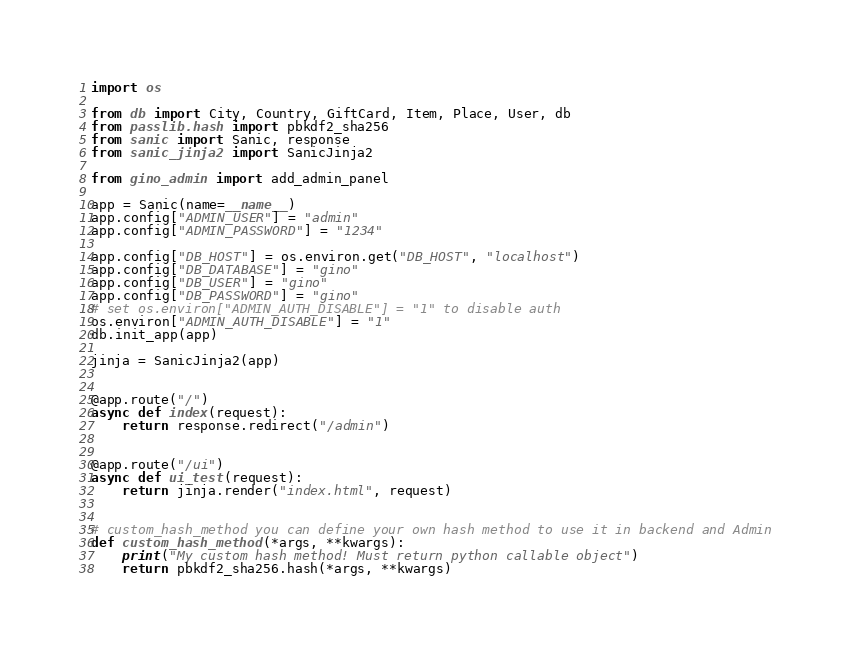Convert code to text. <code><loc_0><loc_0><loc_500><loc_500><_Python_>import os

from db import City, Country, GiftCard, Item, Place, User, db
from passlib.hash import pbkdf2_sha256
from sanic import Sanic, response
from sanic_jinja2 import SanicJinja2

from gino_admin import add_admin_panel

app = Sanic(name=__name__)
app.config["ADMIN_USER"] = "admin"
app.config["ADMIN_PASSWORD"] = "1234"

app.config["DB_HOST"] = os.environ.get("DB_HOST", "localhost")
app.config["DB_DATABASE"] = "gino"
app.config["DB_USER"] = "gino"
app.config["DB_PASSWORD"] = "gino"
# set os.environ["ADMIN_AUTH_DISABLE"] = "1" to disable auth
os.environ["ADMIN_AUTH_DISABLE"] = "1"
db.init_app(app)

jinja = SanicJinja2(app)


@app.route("/")
async def index(request):
    return response.redirect("/admin")


@app.route("/ui")
async def ui_test(request):
    return jinja.render("index.html", request)


# custom_hash_method you can define your own hash method to use it in backend and Admin
def custom_hash_method(*args, **kwargs):
    print("My custom hash method! Must return python callable object")
    return pbkdf2_sha256.hash(*args, **kwargs)

</code> 